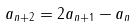Convert formula to latex. <formula><loc_0><loc_0><loc_500><loc_500>a _ { n + 2 } = 2 a _ { n + 1 } - a _ { n }</formula> 